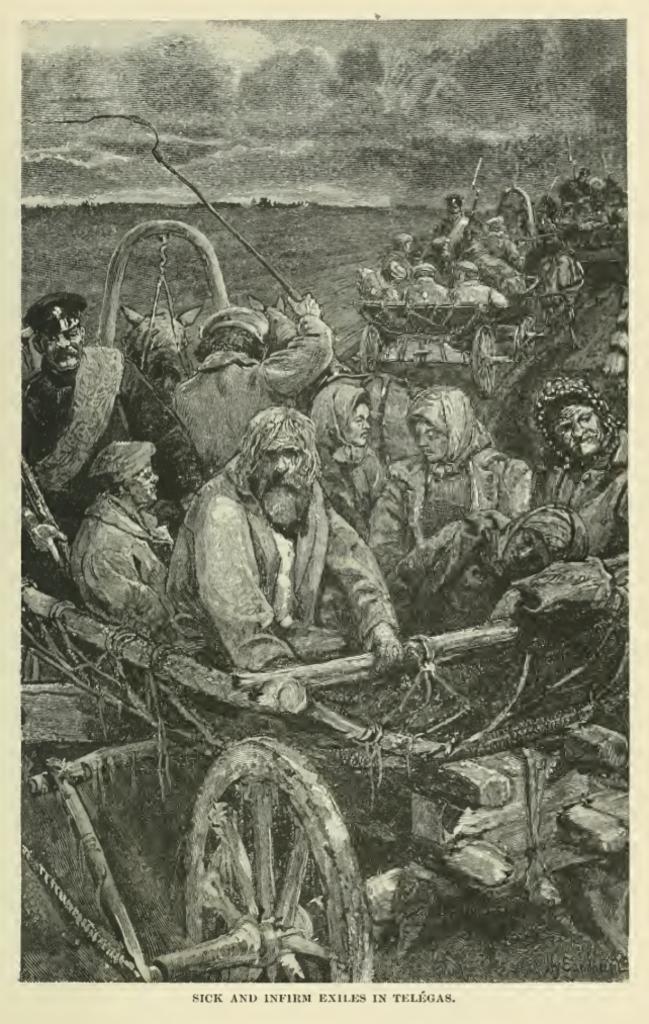How would you summarize this image in a sentence or two? In this image there is a painting with a few people on the carts with some text under it. 